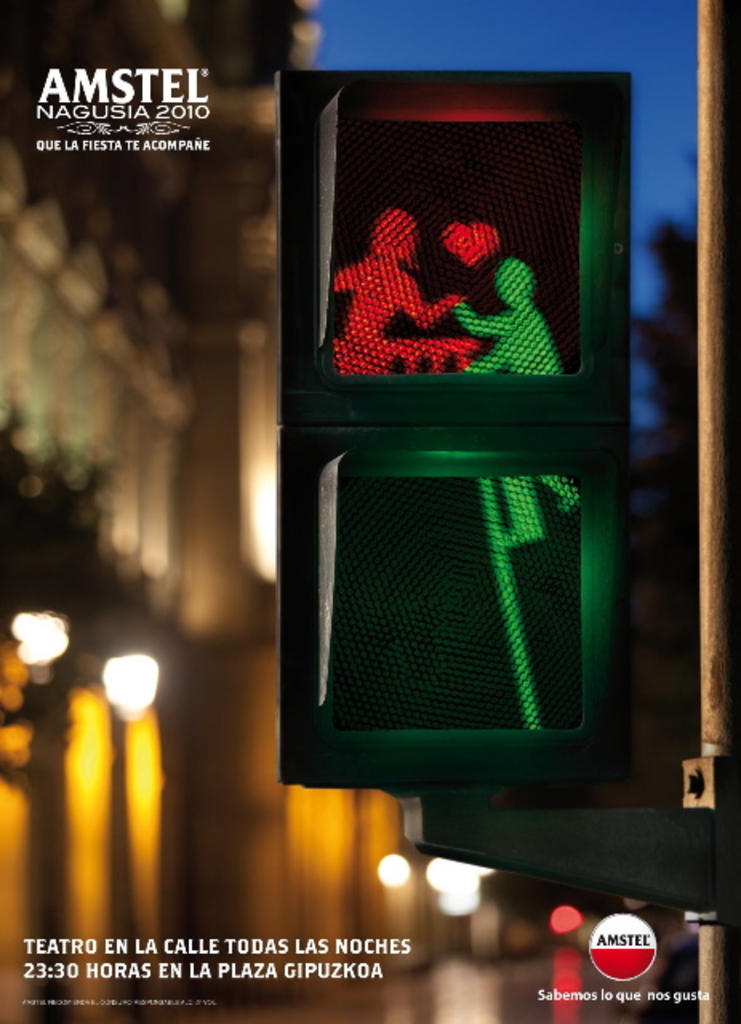Provide a one-sentence caption for the provided image. The image shows a clever Amstel beer advertisement depicting two people having a festive time inside a traffic light, symbolizing the vibrant nightlife promoted by Amstel during the Nagusia festival in 2010. 